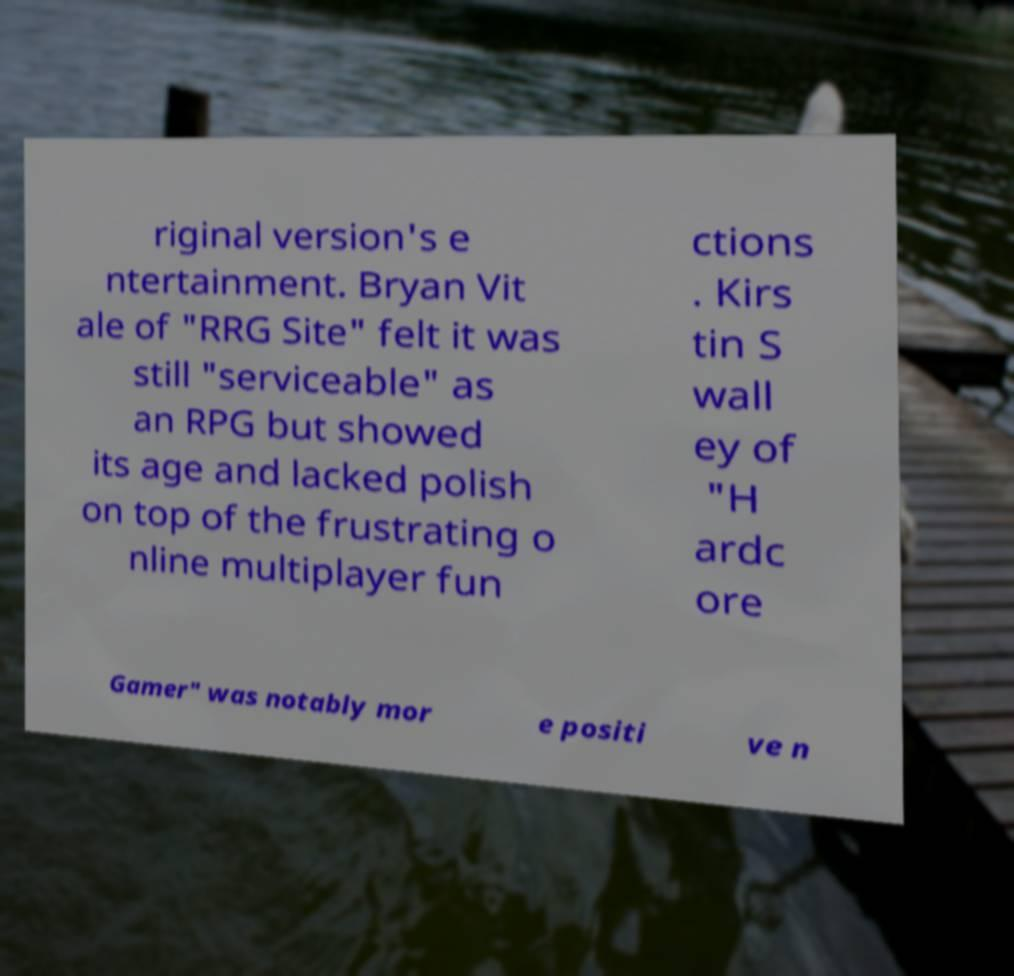Could you extract and type out the text from this image? riginal version's e ntertainment. Bryan Vit ale of "RRG Site" felt it was still "serviceable" as an RPG but showed its age and lacked polish on top of the frustrating o nline multiplayer fun ctions . Kirs tin S wall ey of "H ardc ore Gamer" was notably mor e positi ve n 